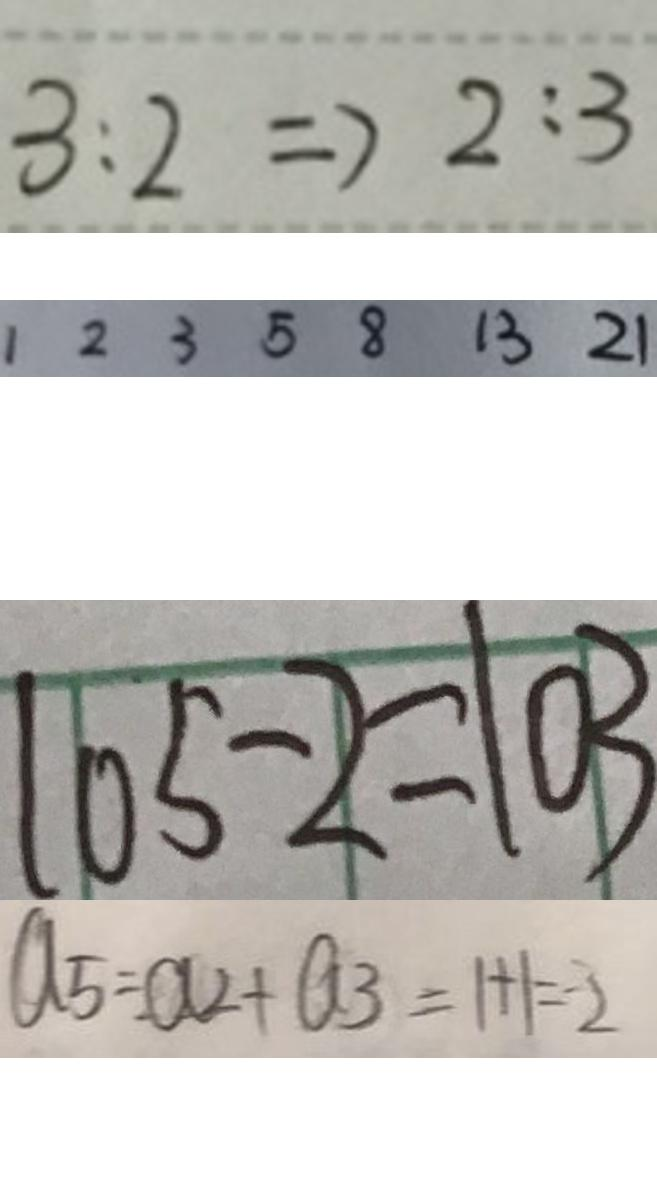Convert formula to latex. <formula><loc_0><loc_0><loc_500><loc_500>3 : 2 \Rightarrow 2 : 3 
 1 2 3 5 8 1 3 2 1 
 1 0 5 - 2 = 1 0 3 
 a _ { 5 } = a _ { 2 } + a _ { 3 } = 1 + 1 = 2</formula> 